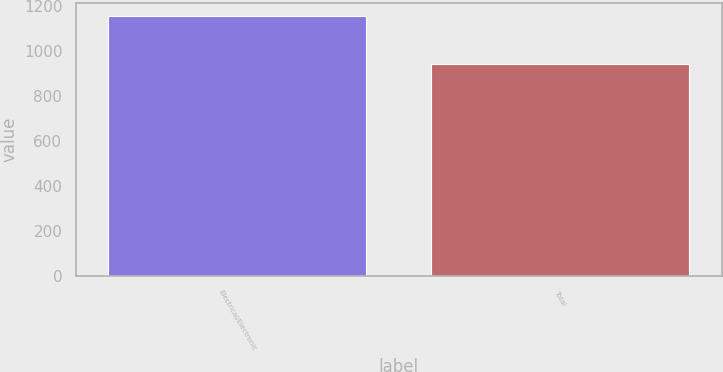Convert chart to OTSL. <chart><loc_0><loc_0><loc_500><loc_500><bar_chart><fcel>Electrical/Electronic<fcel>Total<nl><fcel>1157<fcel>944<nl></chart> 